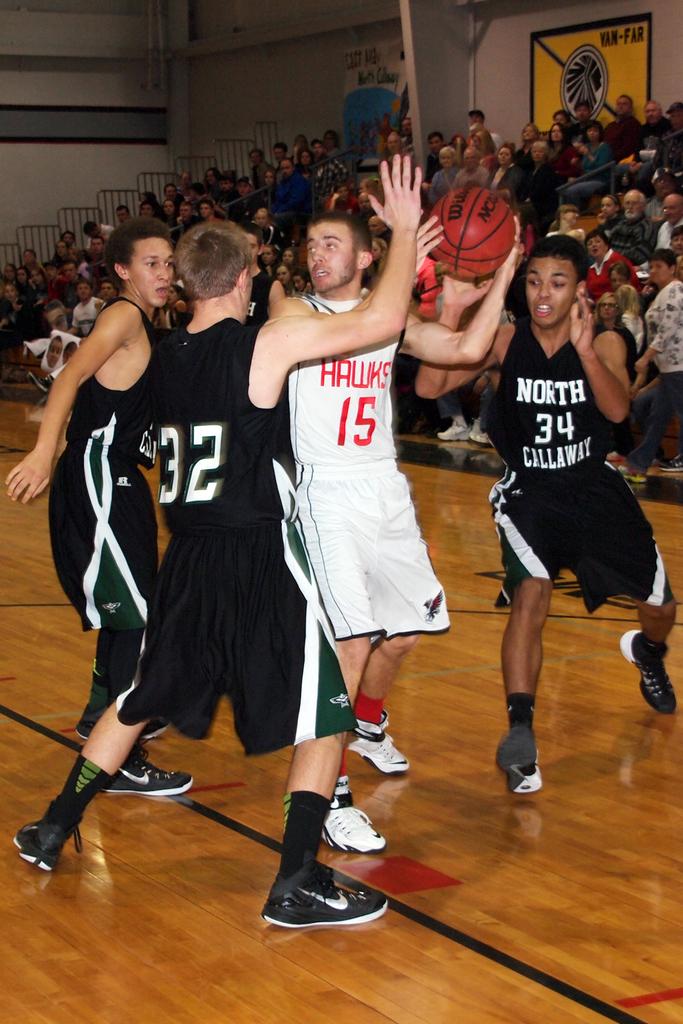What team does the player with the ball play for?
Your answer should be compact. Hawks. What is on the back of the black jersey?
Ensure brevity in your answer.  32. 